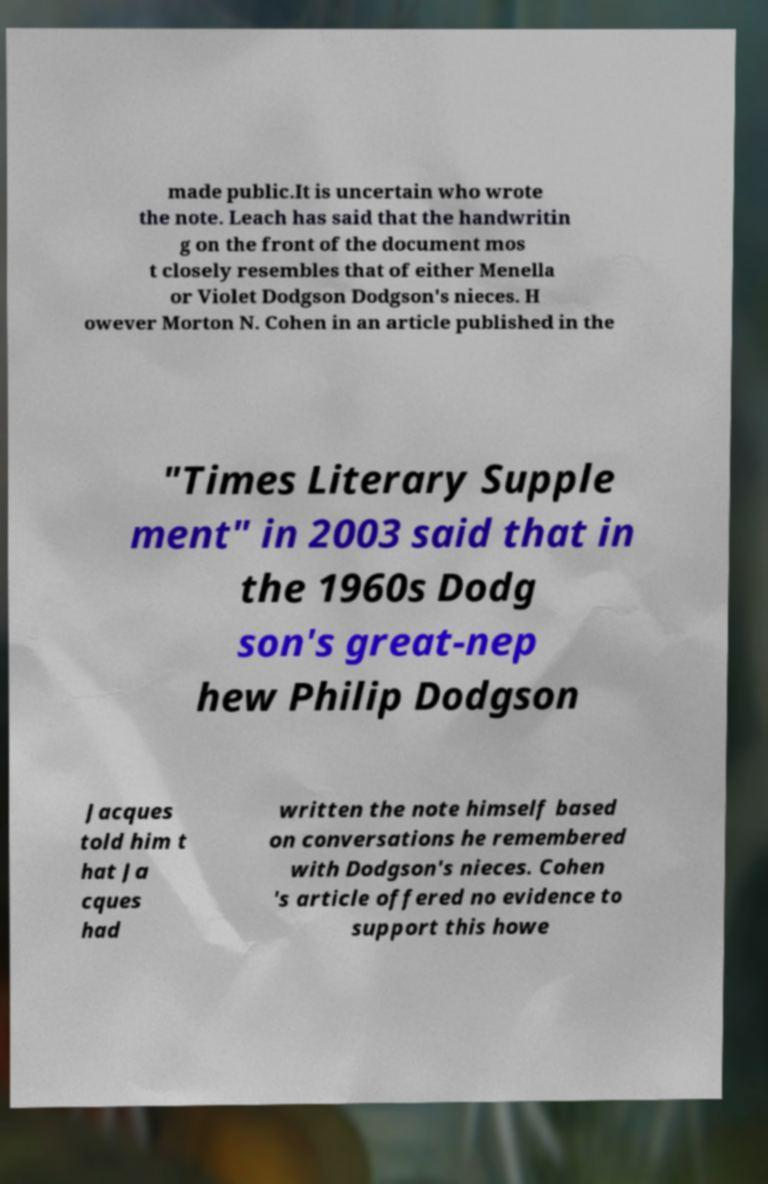Could you extract and type out the text from this image? made public.It is uncertain who wrote the note. Leach has said that the handwritin g on the front of the document mos t closely resembles that of either Menella or Violet Dodgson Dodgson's nieces. H owever Morton N. Cohen in an article published in the "Times Literary Supple ment" in 2003 said that in the 1960s Dodg son's great-nep hew Philip Dodgson Jacques told him t hat Ja cques had written the note himself based on conversations he remembered with Dodgson's nieces. Cohen 's article offered no evidence to support this howe 